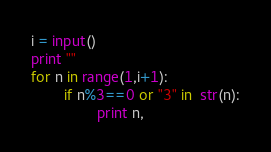<code> <loc_0><loc_0><loc_500><loc_500><_Python_>i = input()
print ""
for n in range(1,i+1):
        if n%3==0 or "3" in  str(n):
                print n,</code> 